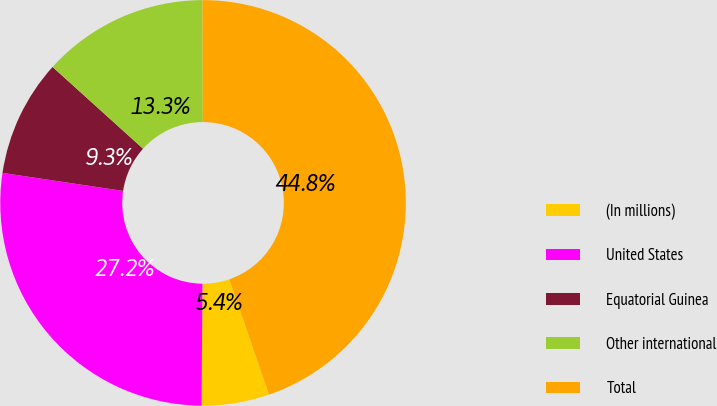<chart> <loc_0><loc_0><loc_500><loc_500><pie_chart><fcel>(In millions)<fcel>United States<fcel>Equatorial Guinea<fcel>Other international<fcel>Total<nl><fcel>5.39%<fcel>27.25%<fcel>9.33%<fcel>13.26%<fcel>44.78%<nl></chart> 